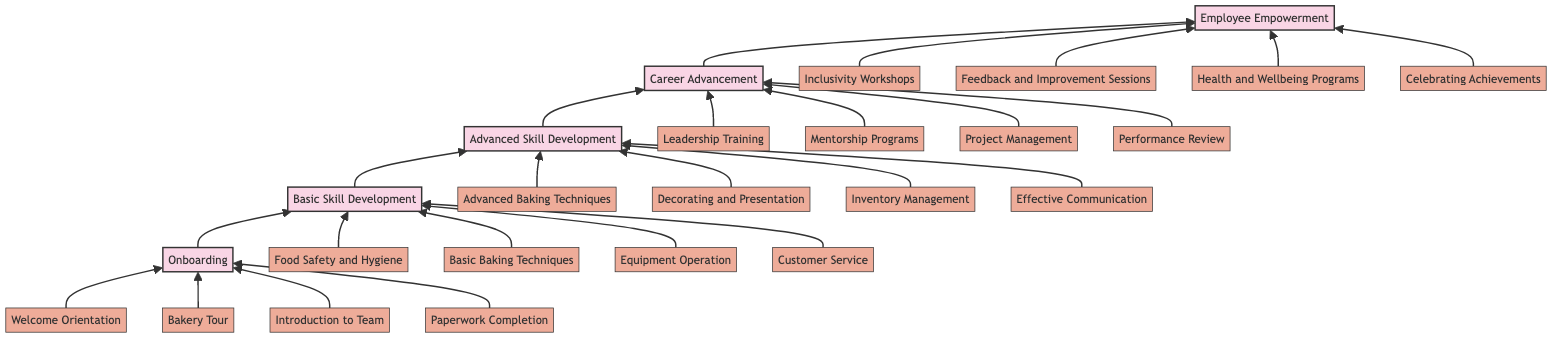What is the final stage of the pathway? The final stage of the pathway is "Employee Empowerment," as it is positioned at the top of the flow chart, indicating the last step in the development process.
Answer: Employee Empowerment How many stages are there in total? There are five stages in total, which are visually represented as separate nodes in the diagram stacked from bottom to top.
Answer: Five What milestone is associated with the "Career Advancement" stage? "Leadership Training" is associated with the "Career Advancement" stage, as it is one of the milestones listed directly under that stage in the flow chart.
Answer: Leadership Training What connects "Advanced Skill Development" to "Career Advancement"? The arrow connecting "Advanced Skill Development" to "Career Advancement" signifies that as employees complete the advanced skills, they progress to career advancement, illustrating the flow of development.
Answer: Arrow Which stage involves inclusivity initiatives? The stage that involves inclusivity initiatives is "Employee Empowerment," since it includes milestones like "Inclusivity Workshops" aimed at fostering an inclusive workplace.
Answer: Employee Empowerment What milestone comes after "Basic Baking Techniques"? "Equipment Operation" comes after "Basic Baking Techniques" as it follows in the list of milestones for the "Basic Skill Development" stage.
Answer: Equipment Operation How many milestones are listed under "Advanced Skill Development"? There are four milestones listed under "Advanced Skill Development," each specifying key areas of skill enhancement within the bakery.
Answer: Four Which stage focuses on food safety? The stage focusing on food safety is "Basic Skill Development," which includes the milestone "Food Safety and Hygiene" as a primary training element.
Answer: Basic Skill Development What is the primary focus of the "Onboarding" stage? The primary focus of the "Onboarding" stage is to introduce new hires to the bakery environment and culture, as stated in the description provided for that stage.
Answer: Introducing new hires to the bakery environment and culture 